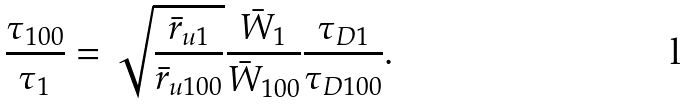<formula> <loc_0><loc_0><loc_500><loc_500>\frac { \tau _ { 1 0 0 } } { \tau _ { 1 } } = \sqrt { \frac { \bar { r } _ { { u } 1 } } { \bar { r } _ { { u } 1 0 0 } } } \frac { \bar { W } _ { 1 } } { \bar { W } _ { 1 0 0 } } \frac { \tau _ { D 1 } } { \tau _ { D 1 0 0 } } .</formula> 